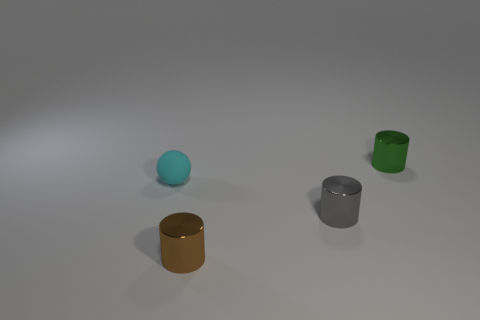What is the color of the small cylinder behind the small cyan rubber object? green 